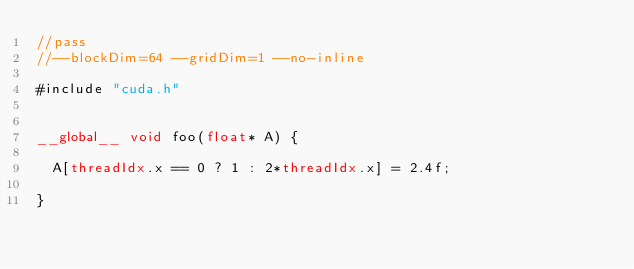Convert code to text. <code><loc_0><loc_0><loc_500><loc_500><_Cuda_>//pass
//--blockDim=64 --gridDim=1 --no-inline

#include "cuda.h"


__global__ void foo(float* A) {

  A[threadIdx.x == 0 ? 1 : 2*threadIdx.x] = 2.4f;

}
</code> 